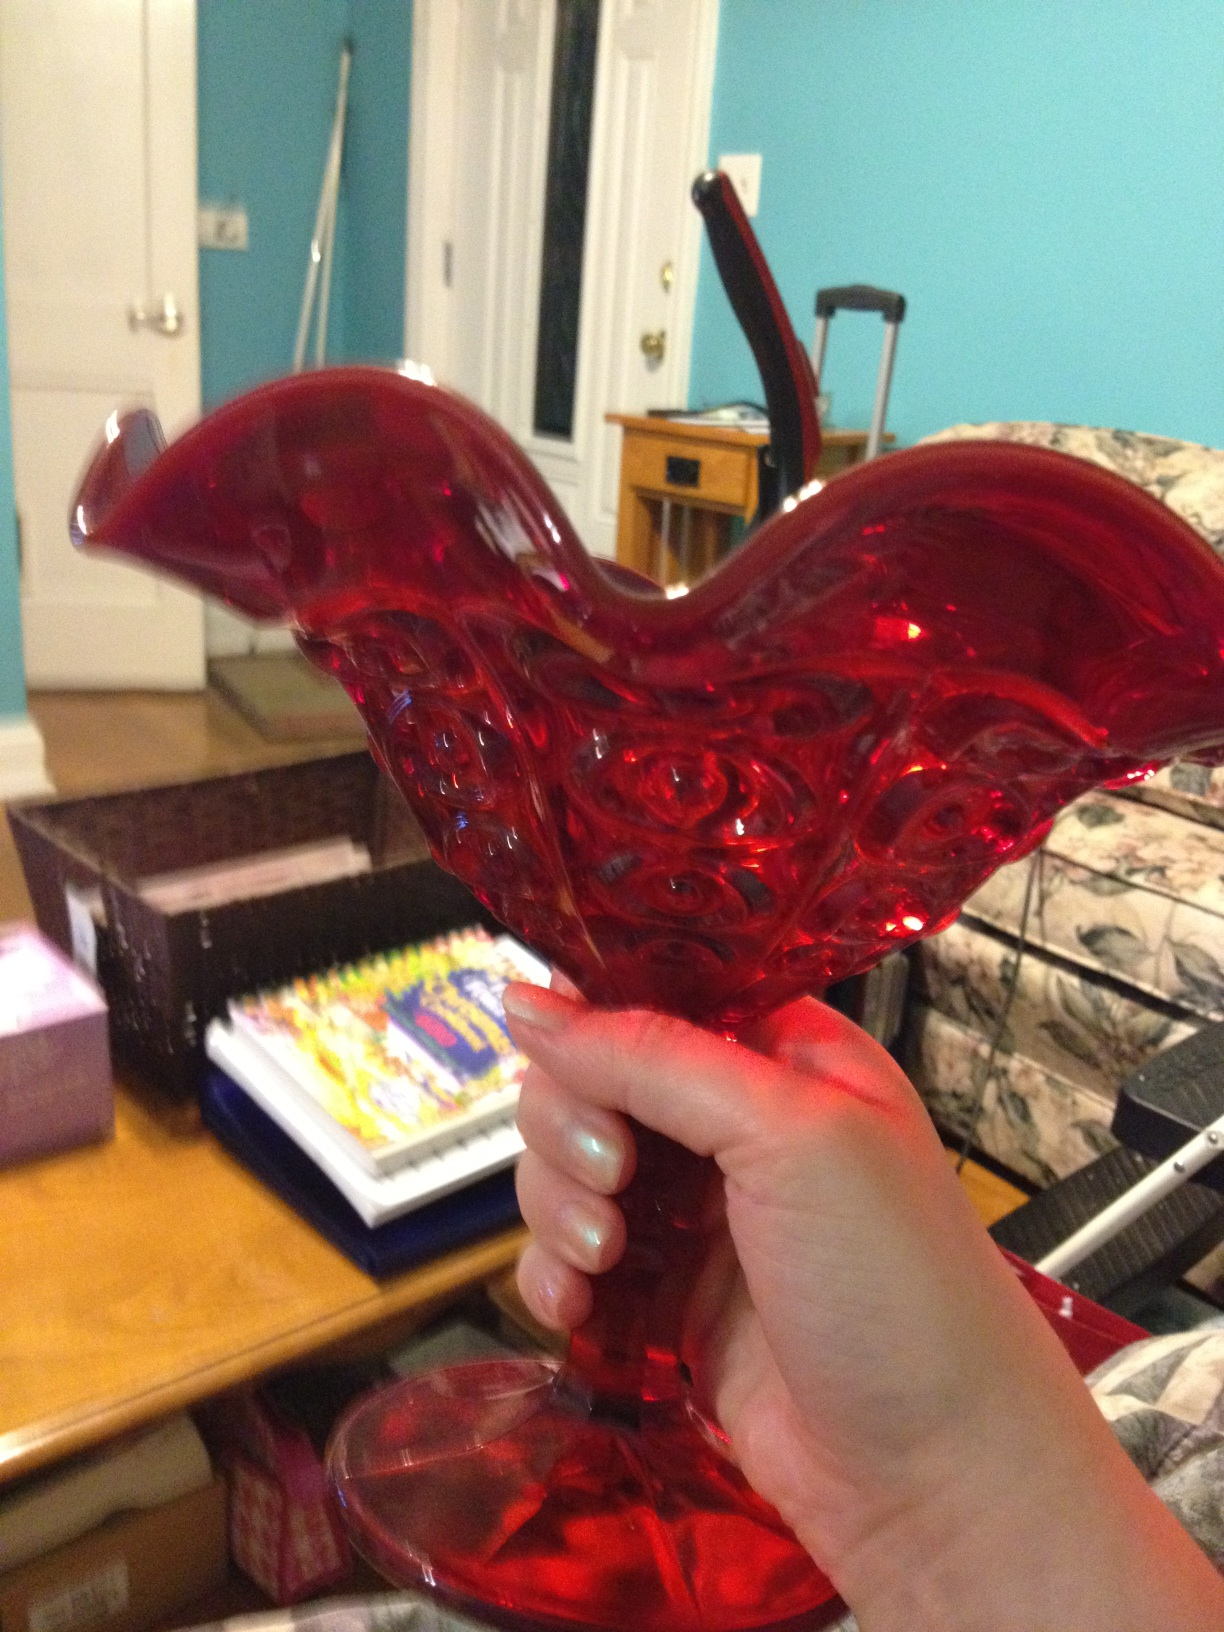Can you imagine a fantastical scenario where this vase plays a key role? In a mystical realm, this vase holds the power to control the elements. When filled with water, it summons rains to nourish lands. When empty, it can conjure flames to protect the kingdom. During a grand festival, it is used to perform enchanting rituals, with its red glow lighting up the night sky and mesmerizing all who witness the spectacle. What practical uses could this vase have in a modern home? In a modern home, this vase can serve various practical purposes. It can be used to display fresh flowers, adding a touch of nature and beauty to any room. Additionally, it could be placed as a centerpiece on a dining table or a mantelpiece, serving as an eye-catching decor item. Its bold color could complement a contemporary interior design theme, acting as a statement piece that enhances the overall aesthetic of the space. Imagine this vase was found in an archaeological dig. What could it tell us about the civilization it came from? If this vase were found in an archaeological dig, it could reveal much about the civilization it originated from. The craftsmanship would indicate the level of artistic and technical skills possessed by the artisans of that era. The material used could provide insights into the resources that were valued and available. The intricate design might reflect cultural or religious symbols significant to the people. Overall, the vase would act as a piece of history, helping us understand the cultural and societal norms, trade practices, and aesthetic values of the civilization it belonged to. 